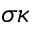<formula> <loc_0><loc_0><loc_500><loc_500>\sigma \kappa</formula> 